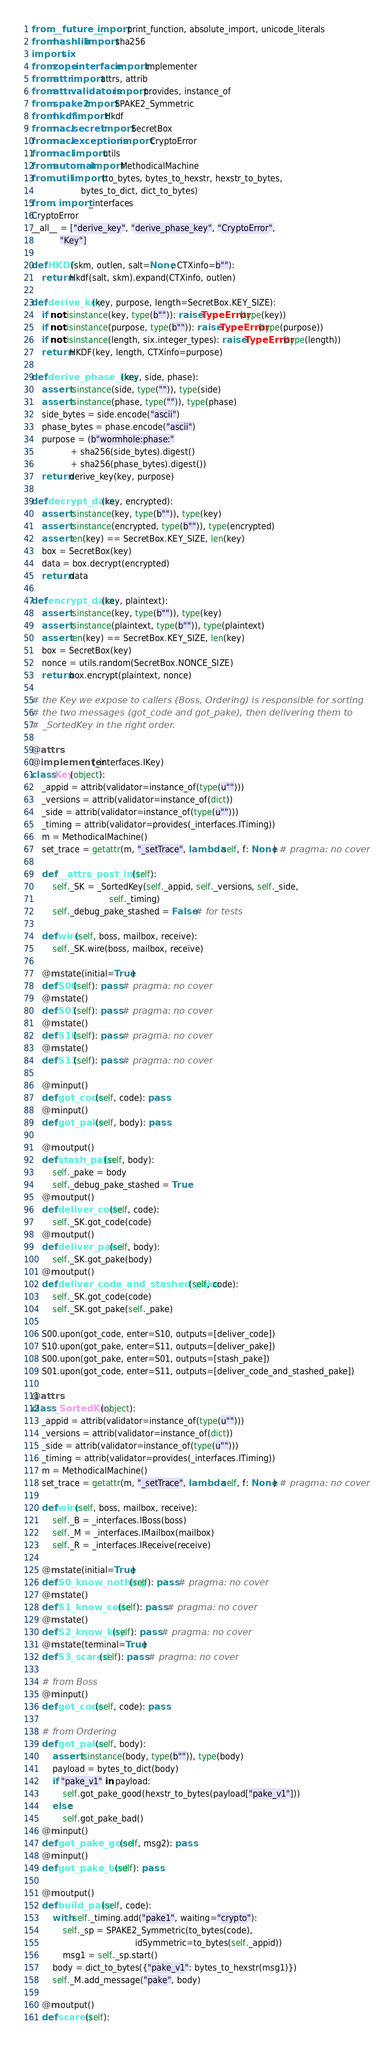Convert code to text. <code><loc_0><loc_0><loc_500><loc_500><_Python_>from __future__ import print_function, absolute_import, unicode_literals
from hashlib import sha256
import six
from zope.interface import implementer
from attr import attrs, attrib
from attr.validators import provides, instance_of
from spake2 import SPAKE2_Symmetric
from hkdf import Hkdf
from nacl.secret import SecretBox
from nacl.exceptions import CryptoError
from nacl import utils
from automat import MethodicalMachine
from .util import (to_bytes, bytes_to_hexstr, hexstr_to_bytes,
                   bytes_to_dict, dict_to_bytes)
from . import _interfaces
CryptoError
__all__ = ["derive_key", "derive_phase_key", "CryptoError",
           "Key"]

def HKDF(skm, outlen, salt=None, CTXinfo=b""):
    return Hkdf(salt, skm).expand(CTXinfo, outlen)

def derive_key(key, purpose, length=SecretBox.KEY_SIZE):
    if not isinstance(key, type(b"")): raise TypeError(type(key))
    if not isinstance(purpose, type(b"")): raise TypeError(type(purpose))
    if not isinstance(length, six.integer_types): raise TypeError(type(length))
    return HKDF(key, length, CTXinfo=purpose)

def derive_phase_key(key, side, phase):
    assert isinstance(side, type("")), type(side)
    assert isinstance(phase, type("")), type(phase)
    side_bytes = side.encode("ascii")
    phase_bytes = phase.encode("ascii")
    purpose = (b"wormhole:phase:"
               + sha256(side_bytes).digest()
               + sha256(phase_bytes).digest())
    return derive_key(key, purpose)

def decrypt_data(key, encrypted):
    assert isinstance(key, type(b"")), type(key)
    assert isinstance(encrypted, type(b"")), type(encrypted)
    assert len(key) == SecretBox.KEY_SIZE, len(key)
    box = SecretBox(key)
    data = box.decrypt(encrypted)
    return data

def encrypt_data(key, plaintext):
    assert isinstance(key, type(b"")), type(key)
    assert isinstance(plaintext, type(b"")), type(plaintext)
    assert len(key) == SecretBox.KEY_SIZE, len(key)
    box = SecretBox(key)
    nonce = utils.random(SecretBox.NONCE_SIZE)
    return box.encrypt(plaintext, nonce)

# the Key we expose to callers (Boss, Ordering) is responsible for sorting
# the two messages (got_code and got_pake), then delivering them to
# _SortedKey in the right order.

@attrs
@implementer(_interfaces.IKey)
class Key(object):
    _appid = attrib(validator=instance_of(type(u"")))
    _versions = attrib(validator=instance_of(dict))
    _side = attrib(validator=instance_of(type(u"")))
    _timing = attrib(validator=provides(_interfaces.ITiming))
    m = MethodicalMachine()
    set_trace = getattr(m, "_setTrace", lambda self, f: None) # pragma: no cover

    def __attrs_post_init__(self):
        self._SK = _SortedKey(self._appid, self._versions, self._side,
                              self._timing)
        self._debug_pake_stashed = False # for tests

    def wire(self, boss, mailbox, receive):
        self._SK.wire(boss, mailbox, receive)

    @m.state(initial=True)
    def S00(self): pass # pragma: no cover
    @m.state()
    def S01(self): pass # pragma: no cover
    @m.state()
    def S10(self): pass # pragma: no cover
    @m.state()
    def S11(self): pass # pragma: no cover

    @m.input()
    def got_code(self, code): pass
    @m.input()
    def got_pake(self, body): pass

    @m.output()
    def stash_pake(self, body):
        self._pake = body
        self._debug_pake_stashed = True
    @m.output()
    def deliver_code(self, code):
        self._SK.got_code(code)
    @m.output()
    def deliver_pake(self, body):
        self._SK.got_pake(body)
    @m.output()
    def deliver_code_and_stashed_pake(self, code):
        self._SK.got_code(code)
        self._SK.got_pake(self._pake)

    S00.upon(got_code, enter=S10, outputs=[deliver_code])
    S10.upon(got_pake, enter=S11, outputs=[deliver_pake])
    S00.upon(got_pake, enter=S01, outputs=[stash_pake])
    S01.upon(got_code, enter=S11, outputs=[deliver_code_and_stashed_pake])

@attrs
class _SortedKey(object):
    _appid = attrib(validator=instance_of(type(u"")))
    _versions = attrib(validator=instance_of(dict))
    _side = attrib(validator=instance_of(type(u"")))
    _timing = attrib(validator=provides(_interfaces.ITiming))
    m = MethodicalMachine()
    set_trace = getattr(m, "_setTrace", lambda self, f: None) # pragma: no cover

    def wire(self, boss, mailbox, receive):
        self._B = _interfaces.IBoss(boss)
        self._M = _interfaces.IMailbox(mailbox)
        self._R = _interfaces.IReceive(receive)

    @m.state(initial=True)
    def S0_know_nothing(self): pass # pragma: no cover
    @m.state()
    def S1_know_code(self): pass # pragma: no cover
    @m.state()
    def S2_know_key(self): pass # pragma: no cover
    @m.state(terminal=True)
    def S3_scared(self): pass # pragma: no cover

    # from Boss
    @m.input()
    def got_code(self, code): pass

    # from Ordering
    def got_pake(self, body):
        assert isinstance(body, type(b"")), type(body)
        payload = bytes_to_dict(body)
        if "pake_v1" in payload:
            self.got_pake_good(hexstr_to_bytes(payload["pake_v1"]))
        else:
            self.got_pake_bad()
    @m.input()
    def got_pake_good(self, msg2): pass
    @m.input()
    def got_pake_bad(self): pass

    @m.output()
    def build_pake(self, code):
        with self._timing.add("pake1", waiting="crypto"):
            self._sp = SPAKE2_Symmetric(to_bytes(code),
                                        idSymmetric=to_bytes(self._appid))
            msg1 = self._sp.start()
        body = dict_to_bytes({"pake_v1": bytes_to_hexstr(msg1)})
        self._M.add_message("pake", body)

    @m.output()
    def scared(self):</code> 